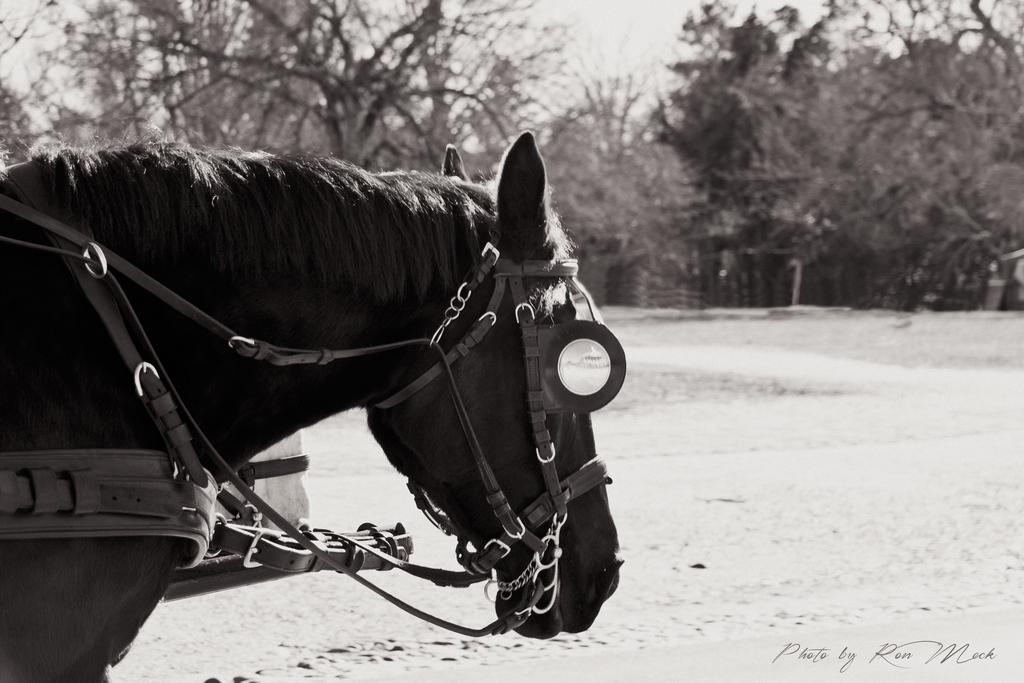What animal is the main subject of the image? There is a horse in the image. What is unique about the horse in the image? The horse has belts. What can be seen in the background of the image? There is a road, trees, and the sky visible in the background of the image. Is there any text or marking in the image? Yes, there is a watermark in the bottom right corner of the image. How many birds are perched on the horse's back in the image? There are no birds present in the image; it features a horse with belts. What type of earth formation is visible in the image? There is no specific earth formation mentioned or visible in the image; it primarily features a horse with belts and a background with a road, trees, and sky. 